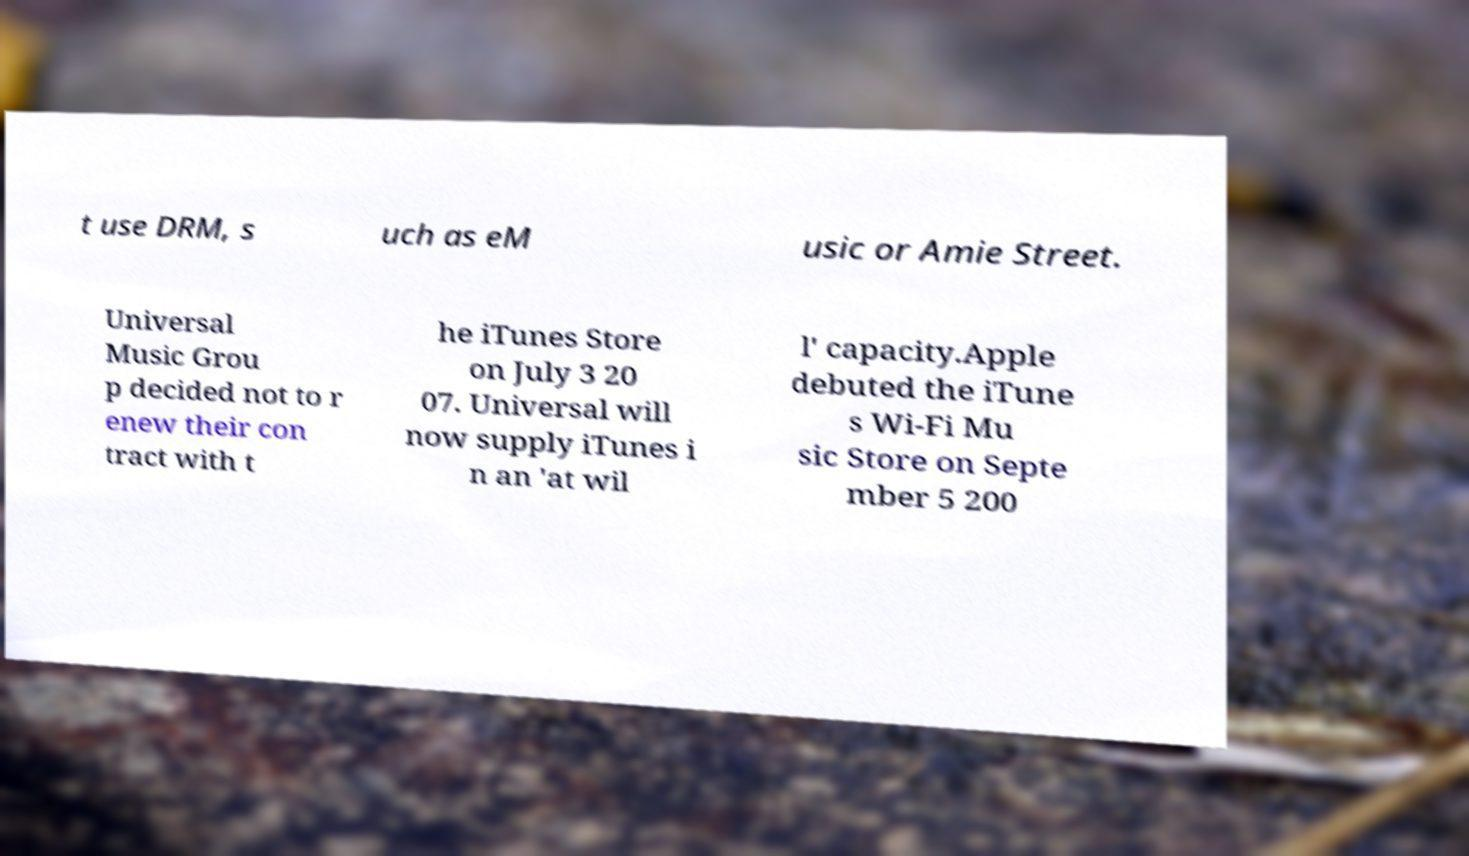I need the written content from this picture converted into text. Can you do that? t use DRM, s uch as eM usic or Amie Street. Universal Music Grou p decided not to r enew their con tract with t he iTunes Store on July 3 20 07. Universal will now supply iTunes i n an 'at wil l' capacity.Apple debuted the iTune s Wi-Fi Mu sic Store on Septe mber 5 200 